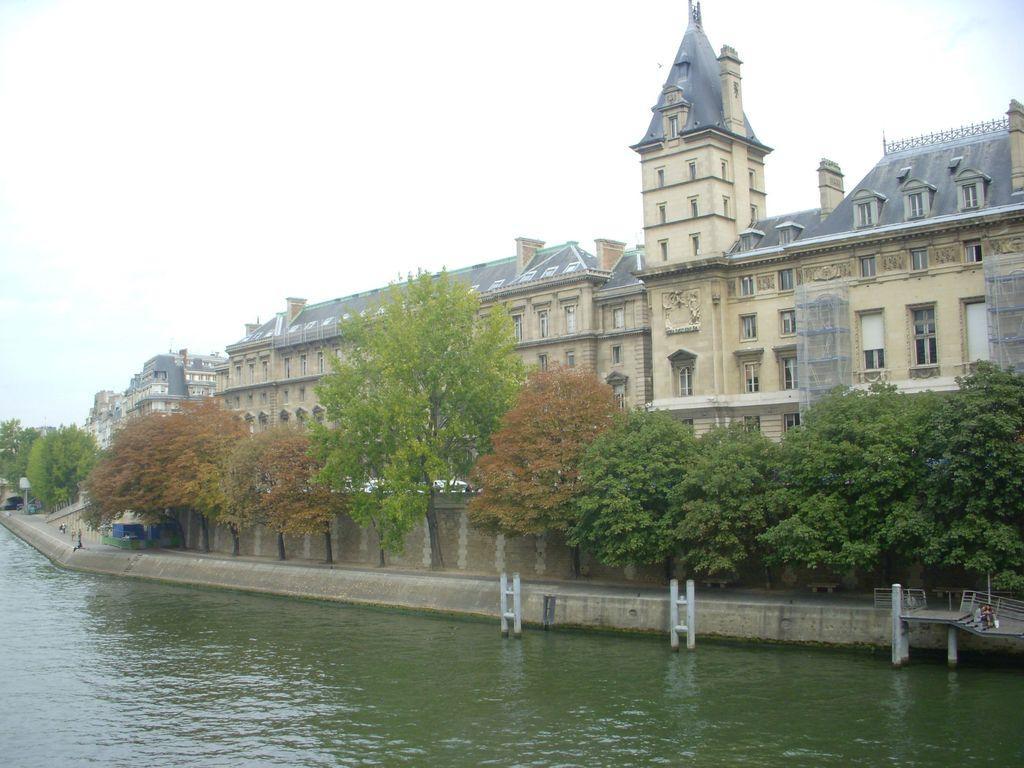Describe this image in one or two sentences. In this picture we can see the sky, buildings, windows, wall, trees, water, railings and few objects. 